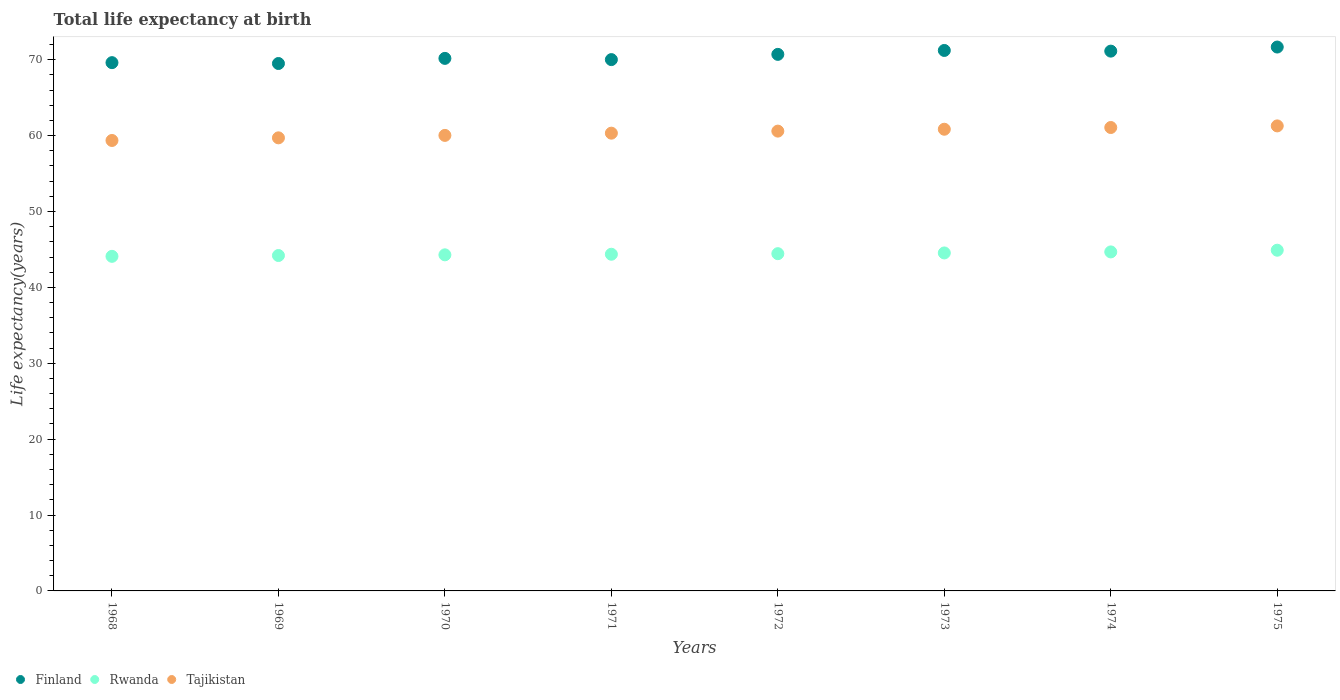How many different coloured dotlines are there?
Your answer should be very brief. 3. What is the life expectancy at birth in in Rwanda in 1970?
Your response must be concise. 44.29. Across all years, what is the maximum life expectancy at birth in in Rwanda?
Make the answer very short. 44.9. Across all years, what is the minimum life expectancy at birth in in Tajikistan?
Make the answer very short. 59.36. In which year was the life expectancy at birth in in Tajikistan maximum?
Ensure brevity in your answer.  1975. In which year was the life expectancy at birth in in Finland minimum?
Provide a short and direct response. 1969. What is the total life expectancy at birth in in Finland in the graph?
Provide a succinct answer. 564.06. What is the difference between the life expectancy at birth in in Finland in 1969 and that in 1972?
Your answer should be very brief. -1.2. What is the difference between the life expectancy at birth in in Rwanda in 1971 and the life expectancy at birth in in Tajikistan in 1975?
Make the answer very short. -16.91. What is the average life expectancy at birth in in Tajikistan per year?
Offer a terse response. 60.4. In the year 1968, what is the difference between the life expectancy at birth in in Tajikistan and life expectancy at birth in in Finland?
Make the answer very short. -10.26. In how many years, is the life expectancy at birth in in Finland greater than 48 years?
Keep it short and to the point. 8. What is the ratio of the life expectancy at birth in in Tajikistan in 1974 to that in 1975?
Ensure brevity in your answer.  1. What is the difference between the highest and the second highest life expectancy at birth in in Finland?
Give a very brief answer. 0.45. What is the difference between the highest and the lowest life expectancy at birth in in Tajikistan?
Ensure brevity in your answer.  1.92. Is the sum of the life expectancy at birth in in Tajikistan in 1969 and 1971 greater than the maximum life expectancy at birth in in Finland across all years?
Your answer should be very brief. Yes. Is it the case that in every year, the sum of the life expectancy at birth in in Tajikistan and life expectancy at birth in in Rwanda  is greater than the life expectancy at birth in in Finland?
Your answer should be compact. Yes. Is the life expectancy at birth in in Tajikistan strictly greater than the life expectancy at birth in in Rwanda over the years?
Offer a very short reply. Yes. How many years are there in the graph?
Your answer should be compact. 8. Does the graph contain grids?
Offer a terse response. No. How many legend labels are there?
Your answer should be compact. 3. How are the legend labels stacked?
Your answer should be very brief. Horizontal. What is the title of the graph?
Make the answer very short. Total life expectancy at birth. Does "Kuwait" appear as one of the legend labels in the graph?
Make the answer very short. No. What is the label or title of the Y-axis?
Make the answer very short. Life expectancy(years). What is the Life expectancy(years) in Finland in 1968?
Make the answer very short. 69.62. What is the Life expectancy(years) in Rwanda in 1968?
Offer a terse response. 44.09. What is the Life expectancy(years) in Tajikistan in 1968?
Your answer should be very brief. 59.36. What is the Life expectancy(years) in Finland in 1969?
Ensure brevity in your answer.  69.5. What is the Life expectancy(years) of Rwanda in 1969?
Make the answer very short. 44.2. What is the Life expectancy(years) in Tajikistan in 1969?
Ensure brevity in your answer.  59.71. What is the Life expectancy(years) of Finland in 1970?
Your response must be concise. 70.18. What is the Life expectancy(years) of Rwanda in 1970?
Make the answer very short. 44.29. What is the Life expectancy(years) of Tajikistan in 1970?
Offer a very short reply. 60.03. What is the Life expectancy(years) in Finland in 1971?
Your answer should be very brief. 70.02. What is the Life expectancy(years) in Rwanda in 1971?
Provide a succinct answer. 44.37. What is the Life expectancy(years) of Tajikistan in 1971?
Make the answer very short. 60.32. What is the Life expectancy(years) of Finland in 1972?
Make the answer very short. 70.71. What is the Life expectancy(years) of Rwanda in 1972?
Ensure brevity in your answer.  44.44. What is the Life expectancy(years) of Tajikistan in 1972?
Make the answer very short. 60.59. What is the Life expectancy(years) of Finland in 1973?
Offer a very short reply. 71.22. What is the Life expectancy(years) in Rwanda in 1973?
Provide a short and direct response. 44.54. What is the Life expectancy(years) of Tajikistan in 1973?
Offer a very short reply. 60.84. What is the Life expectancy(years) in Finland in 1974?
Provide a succinct answer. 71.13. What is the Life expectancy(years) in Rwanda in 1974?
Your response must be concise. 44.67. What is the Life expectancy(years) of Tajikistan in 1974?
Ensure brevity in your answer.  61.07. What is the Life expectancy(years) in Finland in 1975?
Your answer should be compact. 71.67. What is the Life expectancy(years) in Rwanda in 1975?
Provide a succinct answer. 44.9. What is the Life expectancy(years) in Tajikistan in 1975?
Your answer should be compact. 61.28. Across all years, what is the maximum Life expectancy(years) in Finland?
Offer a very short reply. 71.67. Across all years, what is the maximum Life expectancy(years) of Rwanda?
Your answer should be compact. 44.9. Across all years, what is the maximum Life expectancy(years) of Tajikistan?
Ensure brevity in your answer.  61.28. Across all years, what is the minimum Life expectancy(years) of Finland?
Make the answer very short. 69.5. Across all years, what is the minimum Life expectancy(years) in Rwanda?
Your answer should be compact. 44.09. Across all years, what is the minimum Life expectancy(years) of Tajikistan?
Provide a short and direct response. 59.36. What is the total Life expectancy(years) of Finland in the graph?
Ensure brevity in your answer.  564.06. What is the total Life expectancy(years) in Rwanda in the graph?
Keep it short and to the point. 355.51. What is the total Life expectancy(years) in Tajikistan in the graph?
Provide a short and direct response. 483.21. What is the difference between the Life expectancy(years) in Finland in 1968 and that in 1969?
Offer a terse response. 0.11. What is the difference between the Life expectancy(years) in Rwanda in 1968 and that in 1969?
Your answer should be very brief. -0.11. What is the difference between the Life expectancy(years) in Tajikistan in 1968 and that in 1969?
Keep it short and to the point. -0.35. What is the difference between the Life expectancy(years) in Finland in 1968 and that in 1970?
Keep it short and to the point. -0.56. What is the difference between the Life expectancy(years) of Rwanda in 1968 and that in 1970?
Offer a terse response. -0.2. What is the difference between the Life expectancy(years) in Tajikistan in 1968 and that in 1970?
Give a very brief answer. -0.67. What is the difference between the Life expectancy(years) of Finland in 1968 and that in 1971?
Your response must be concise. -0.4. What is the difference between the Life expectancy(years) in Rwanda in 1968 and that in 1971?
Make the answer very short. -0.28. What is the difference between the Life expectancy(years) of Tajikistan in 1968 and that in 1971?
Provide a short and direct response. -0.96. What is the difference between the Life expectancy(years) in Finland in 1968 and that in 1972?
Keep it short and to the point. -1.09. What is the difference between the Life expectancy(years) in Rwanda in 1968 and that in 1972?
Make the answer very short. -0.35. What is the difference between the Life expectancy(years) of Tajikistan in 1968 and that in 1972?
Your answer should be very brief. -1.23. What is the difference between the Life expectancy(years) of Finland in 1968 and that in 1973?
Offer a very short reply. -1.61. What is the difference between the Life expectancy(years) in Rwanda in 1968 and that in 1973?
Provide a short and direct response. -0.45. What is the difference between the Life expectancy(years) in Tajikistan in 1968 and that in 1973?
Your answer should be compact. -1.48. What is the difference between the Life expectancy(years) in Finland in 1968 and that in 1974?
Provide a short and direct response. -1.52. What is the difference between the Life expectancy(years) of Rwanda in 1968 and that in 1974?
Give a very brief answer. -0.58. What is the difference between the Life expectancy(years) in Tajikistan in 1968 and that in 1974?
Ensure brevity in your answer.  -1.71. What is the difference between the Life expectancy(years) in Finland in 1968 and that in 1975?
Ensure brevity in your answer.  -2.06. What is the difference between the Life expectancy(years) of Rwanda in 1968 and that in 1975?
Offer a terse response. -0.81. What is the difference between the Life expectancy(years) in Tajikistan in 1968 and that in 1975?
Make the answer very short. -1.92. What is the difference between the Life expectancy(years) of Finland in 1969 and that in 1970?
Provide a short and direct response. -0.68. What is the difference between the Life expectancy(years) in Rwanda in 1969 and that in 1970?
Offer a terse response. -0.09. What is the difference between the Life expectancy(years) in Tajikistan in 1969 and that in 1970?
Make the answer very short. -0.32. What is the difference between the Life expectancy(years) in Finland in 1969 and that in 1971?
Offer a very short reply. -0.51. What is the difference between the Life expectancy(years) in Rwanda in 1969 and that in 1971?
Your response must be concise. -0.17. What is the difference between the Life expectancy(years) in Tajikistan in 1969 and that in 1971?
Provide a short and direct response. -0.62. What is the difference between the Life expectancy(years) of Finland in 1969 and that in 1972?
Offer a very short reply. -1.2. What is the difference between the Life expectancy(years) in Rwanda in 1969 and that in 1972?
Provide a succinct answer. -0.24. What is the difference between the Life expectancy(years) in Tajikistan in 1969 and that in 1972?
Offer a terse response. -0.89. What is the difference between the Life expectancy(years) in Finland in 1969 and that in 1973?
Your answer should be compact. -1.72. What is the difference between the Life expectancy(years) in Rwanda in 1969 and that in 1973?
Provide a short and direct response. -0.34. What is the difference between the Life expectancy(years) in Tajikistan in 1969 and that in 1973?
Offer a very short reply. -1.13. What is the difference between the Life expectancy(years) in Finland in 1969 and that in 1974?
Keep it short and to the point. -1.63. What is the difference between the Life expectancy(years) in Rwanda in 1969 and that in 1974?
Offer a terse response. -0.48. What is the difference between the Life expectancy(years) of Tajikistan in 1969 and that in 1974?
Give a very brief answer. -1.36. What is the difference between the Life expectancy(years) of Finland in 1969 and that in 1975?
Offer a terse response. -2.17. What is the difference between the Life expectancy(years) in Rwanda in 1969 and that in 1975?
Offer a terse response. -0.7. What is the difference between the Life expectancy(years) of Tajikistan in 1969 and that in 1975?
Make the answer very short. -1.57. What is the difference between the Life expectancy(years) of Finland in 1970 and that in 1971?
Provide a short and direct response. 0.16. What is the difference between the Life expectancy(years) in Rwanda in 1970 and that in 1971?
Your answer should be compact. -0.08. What is the difference between the Life expectancy(years) in Tajikistan in 1970 and that in 1971?
Your answer should be compact. -0.29. What is the difference between the Life expectancy(years) in Finland in 1970 and that in 1972?
Offer a terse response. -0.53. What is the difference between the Life expectancy(years) in Rwanda in 1970 and that in 1972?
Offer a terse response. -0.15. What is the difference between the Life expectancy(years) in Tajikistan in 1970 and that in 1972?
Provide a succinct answer. -0.56. What is the difference between the Life expectancy(years) of Finland in 1970 and that in 1973?
Offer a very short reply. -1.04. What is the difference between the Life expectancy(years) in Rwanda in 1970 and that in 1973?
Provide a short and direct response. -0.25. What is the difference between the Life expectancy(years) of Tajikistan in 1970 and that in 1973?
Give a very brief answer. -0.81. What is the difference between the Life expectancy(years) of Finland in 1970 and that in 1974?
Your answer should be very brief. -0.96. What is the difference between the Life expectancy(years) in Rwanda in 1970 and that in 1974?
Your answer should be very brief. -0.38. What is the difference between the Life expectancy(years) of Tajikistan in 1970 and that in 1974?
Provide a short and direct response. -1.04. What is the difference between the Life expectancy(years) in Finland in 1970 and that in 1975?
Offer a very short reply. -1.49. What is the difference between the Life expectancy(years) in Rwanda in 1970 and that in 1975?
Your answer should be compact. -0.61. What is the difference between the Life expectancy(years) in Tajikistan in 1970 and that in 1975?
Make the answer very short. -1.25. What is the difference between the Life expectancy(years) of Finland in 1971 and that in 1972?
Make the answer very short. -0.69. What is the difference between the Life expectancy(years) in Rwanda in 1971 and that in 1972?
Your response must be concise. -0.08. What is the difference between the Life expectancy(years) in Tajikistan in 1971 and that in 1972?
Ensure brevity in your answer.  -0.27. What is the difference between the Life expectancy(years) in Finland in 1971 and that in 1973?
Keep it short and to the point. -1.21. What is the difference between the Life expectancy(years) of Rwanda in 1971 and that in 1973?
Offer a very short reply. -0.17. What is the difference between the Life expectancy(years) in Tajikistan in 1971 and that in 1973?
Your response must be concise. -0.52. What is the difference between the Life expectancy(years) of Finland in 1971 and that in 1974?
Your answer should be very brief. -1.12. What is the difference between the Life expectancy(years) of Rwanda in 1971 and that in 1974?
Offer a very short reply. -0.31. What is the difference between the Life expectancy(years) in Tajikistan in 1971 and that in 1974?
Keep it short and to the point. -0.75. What is the difference between the Life expectancy(years) of Finland in 1971 and that in 1975?
Your response must be concise. -1.66. What is the difference between the Life expectancy(years) in Rwanda in 1971 and that in 1975?
Your answer should be very brief. -0.53. What is the difference between the Life expectancy(years) in Tajikistan in 1971 and that in 1975?
Offer a very short reply. -0.96. What is the difference between the Life expectancy(years) in Finland in 1972 and that in 1973?
Make the answer very short. -0.52. What is the difference between the Life expectancy(years) of Rwanda in 1972 and that in 1973?
Keep it short and to the point. -0.1. What is the difference between the Life expectancy(years) in Tajikistan in 1972 and that in 1973?
Make the answer very short. -0.25. What is the difference between the Life expectancy(years) of Finland in 1972 and that in 1974?
Your answer should be very brief. -0.43. What is the difference between the Life expectancy(years) in Rwanda in 1972 and that in 1974?
Your answer should be compact. -0.23. What is the difference between the Life expectancy(years) in Tajikistan in 1972 and that in 1974?
Give a very brief answer. -0.47. What is the difference between the Life expectancy(years) of Finland in 1972 and that in 1975?
Make the answer very short. -0.97. What is the difference between the Life expectancy(years) in Rwanda in 1972 and that in 1975?
Your answer should be very brief. -0.46. What is the difference between the Life expectancy(years) of Tajikistan in 1972 and that in 1975?
Your response must be concise. -0.69. What is the difference between the Life expectancy(years) of Finland in 1973 and that in 1974?
Offer a terse response. 0.09. What is the difference between the Life expectancy(years) of Rwanda in 1973 and that in 1974?
Offer a very short reply. -0.14. What is the difference between the Life expectancy(years) of Tajikistan in 1973 and that in 1974?
Offer a terse response. -0.23. What is the difference between the Life expectancy(years) in Finland in 1973 and that in 1975?
Provide a succinct answer. -0.45. What is the difference between the Life expectancy(years) in Rwanda in 1973 and that in 1975?
Offer a very short reply. -0.36. What is the difference between the Life expectancy(years) in Tajikistan in 1973 and that in 1975?
Give a very brief answer. -0.44. What is the difference between the Life expectancy(years) of Finland in 1974 and that in 1975?
Keep it short and to the point. -0.54. What is the difference between the Life expectancy(years) in Rwanda in 1974 and that in 1975?
Your response must be concise. -0.22. What is the difference between the Life expectancy(years) of Tajikistan in 1974 and that in 1975?
Your response must be concise. -0.21. What is the difference between the Life expectancy(years) of Finland in 1968 and the Life expectancy(years) of Rwanda in 1969?
Provide a short and direct response. 25.42. What is the difference between the Life expectancy(years) in Finland in 1968 and the Life expectancy(years) in Tajikistan in 1969?
Provide a short and direct response. 9.91. What is the difference between the Life expectancy(years) in Rwanda in 1968 and the Life expectancy(years) in Tajikistan in 1969?
Ensure brevity in your answer.  -15.62. What is the difference between the Life expectancy(years) of Finland in 1968 and the Life expectancy(years) of Rwanda in 1970?
Provide a succinct answer. 25.33. What is the difference between the Life expectancy(years) in Finland in 1968 and the Life expectancy(years) in Tajikistan in 1970?
Make the answer very short. 9.59. What is the difference between the Life expectancy(years) in Rwanda in 1968 and the Life expectancy(years) in Tajikistan in 1970?
Offer a terse response. -15.94. What is the difference between the Life expectancy(years) of Finland in 1968 and the Life expectancy(years) of Rwanda in 1971?
Keep it short and to the point. 25.25. What is the difference between the Life expectancy(years) of Finland in 1968 and the Life expectancy(years) of Tajikistan in 1971?
Your answer should be compact. 9.29. What is the difference between the Life expectancy(years) of Rwanda in 1968 and the Life expectancy(years) of Tajikistan in 1971?
Your response must be concise. -16.23. What is the difference between the Life expectancy(years) of Finland in 1968 and the Life expectancy(years) of Rwanda in 1972?
Ensure brevity in your answer.  25.17. What is the difference between the Life expectancy(years) of Finland in 1968 and the Life expectancy(years) of Tajikistan in 1972?
Your response must be concise. 9.02. What is the difference between the Life expectancy(years) of Rwanda in 1968 and the Life expectancy(years) of Tajikistan in 1972?
Keep it short and to the point. -16.5. What is the difference between the Life expectancy(years) of Finland in 1968 and the Life expectancy(years) of Rwanda in 1973?
Your response must be concise. 25.08. What is the difference between the Life expectancy(years) of Finland in 1968 and the Life expectancy(years) of Tajikistan in 1973?
Ensure brevity in your answer.  8.77. What is the difference between the Life expectancy(years) of Rwanda in 1968 and the Life expectancy(years) of Tajikistan in 1973?
Ensure brevity in your answer.  -16.75. What is the difference between the Life expectancy(years) in Finland in 1968 and the Life expectancy(years) in Rwanda in 1974?
Ensure brevity in your answer.  24.94. What is the difference between the Life expectancy(years) in Finland in 1968 and the Life expectancy(years) in Tajikistan in 1974?
Your answer should be very brief. 8.55. What is the difference between the Life expectancy(years) of Rwanda in 1968 and the Life expectancy(years) of Tajikistan in 1974?
Make the answer very short. -16.98. What is the difference between the Life expectancy(years) of Finland in 1968 and the Life expectancy(years) of Rwanda in 1975?
Give a very brief answer. 24.72. What is the difference between the Life expectancy(years) of Finland in 1968 and the Life expectancy(years) of Tajikistan in 1975?
Your answer should be very brief. 8.34. What is the difference between the Life expectancy(years) in Rwanda in 1968 and the Life expectancy(years) in Tajikistan in 1975?
Give a very brief answer. -17.19. What is the difference between the Life expectancy(years) in Finland in 1969 and the Life expectancy(years) in Rwanda in 1970?
Provide a succinct answer. 25.21. What is the difference between the Life expectancy(years) in Finland in 1969 and the Life expectancy(years) in Tajikistan in 1970?
Make the answer very short. 9.47. What is the difference between the Life expectancy(years) in Rwanda in 1969 and the Life expectancy(years) in Tajikistan in 1970?
Give a very brief answer. -15.83. What is the difference between the Life expectancy(years) of Finland in 1969 and the Life expectancy(years) of Rwanda in 1971?
Keep it short and to the point. 25.14. What is the difference between the Life expectancy(years) in Finland in 1969 and the Life expectancy(years) in Tajikistan in 1971?
Your answer should be compact. 9.18. What is the difference between the Life expectancy(years) in Rwanda in 1969 and the Life expectancy(years) in Tajikistan in 1971?
Provide a succinct answer. -16.12. What is the difference between the Life expectancy(years) of Finland in 1969 and the Life expectancy(years) of Rwanda in 1972?
Your answer should be very brief. 25.06. What is the difference between the Life expectancy(years) of Finland in 1969 and the Life expectancy(years) of Tajikistan in 1972?
Keep it short and to the point. 8.91. What is the difference between the Life expectancy(years) in Rwanda in 1969 and the Life expectancy(years) in Tajikistan in 1972?
Provide a short and direct response. -16.39. What is the difference between the Life expectancy(years) in Finland in 1969 and the Life expectancy(years) in Rwanda in 1973?
Your response must be concise. 24.96. What is the difference between the Life expectancy(years) of Finland in 1969 and the Life expectancy(years) of Tajikistan in 1973?
Make the answer very short. 8.66. What is the difference between the Life expectancy(years) in Rwanda in 1969 and the Life expectancy(years) in Tajikistan in 1973?
Make the answer very short. -16.64. What is the difference between the Life expectancy(years) of Finland in 1969 and the Life expectancy(years) of Rwanda in 1974?
Your answer should be very brief. 24.83. What is the difference between the Life expectancy(years) in Finland in 1969 and the Life expectancy(years) in Tajikistan in 1974?
Ensure brevity in your answer.  8.43. What is the difference between the Life expectancy(years) of Rwanda in 1969 and the Life expectancy(years) of Tajikistan in 1974?
Provide a short and direct response. -16.87. What is the difference between the Life expectancy(years) of Finland in 1969 and the Life expectancy(years) of Rwanda in 1975?
Ensure brevity in your answer.  24.6. What is the difference between the Life expectancy(years) in Finland in 1969 and the Life expectancy(years) in Tajikistan in 1975?
Keep it short and to the point. 8.22. What is the difference between the Life expectancy(years) of Rwanda in 1969 and the Life expectancy(years) of Tajikistan in 1975?
Give a very brief answer. -17.08. What is the difference between the Life expectancy(years) in Finland in 1970 and the Life expectancy(years) in Rwanda in 1971?
Provide a short and direct response. 25.81. What is the difference between the Life expectancy(years) of Finland in 1970 and the Life expectancy(years) of Tajikistan in 1971?
Keep it short and to the point. 9.86. What is the difference between the Life expectancy(years) of Rwanda in 1970 and the Life expectancy(years) of Tajikistan in 1971?
Ensure brevity in your answer.  -16.03. What is the difference between the Life expectancy(years) of Finland in 1970 and the Life expectancy(years) of Rwanda in 1972?
Give a very brief answer. 25.74. What is the difference between the Life expectancy(years) of Finland in 1970 and the Life expectancy(years) of Tajikistan in 1972?
Your answer should be compact. 9.59. What is the difference between the Life expectancy(years) in Rwanda in 1970 and the Life expectancy(years) in Tajikistan in 1972?
Give a very brief answer. -16.3. What is the difference between the Life expectancy(years) in Finland in 1970 and the Life expectancy(years) in Rwanda in 1973?
Provide a succinct answer. 25.64. What is the difference between the Life expectancy(years) in Finland in 1970 and the Life expectancy(years) in Tajikistan in 1973?
Offer a terse response. 9.34. What is the difference between the Life expectancy(years) in Rwanda in 1970 and the Life expectancy(years) in Tajikistan in 1973?
Give a very brief answer. -16.55. What is the difference between the Life expectancy(years) in Finland in 1970 and the Life expectancy(years) in Rwanda in 1974?
Provide a short and direct response. 25.5. What is the difference between the Life expectancy(years) in Finland in 1970 and the Life expectancy(years) in Tajikistan in 1974?
Ensure brevity in your answer.  9.11. What is the difference between the Life expectancy(years) of Rwanda in 1970 and the Life expectancy(years) of Tajikistan in 1974?
Ensure brevity in your answer.  -16.78. What is the difference between the Life expectancy(years) of Finland in 1970 and the Life expectancy(years) of Rwanda in 1975?
Provide a short and direct response. 25.28. What is the difference between the Life expectancy(years) in Finland in 1970 and the Life expectancy(years) in Tajikistan in 1975?
Your response must be concise. 8.9. What is the difference between the Life expectancy(years) in Rwanda in 1970 and the Life expectancy(years) in Tajikistan in 1975?
Provide a short and direct response. -16.99. What is the difference between the Life expectancy(years) of Finland in 1971 and the Life expectancy(years) of Rwanda in 1972?
Provide a succinct answer. 25.57. What is the difference between the Life expectancy(years) in Finland in 1971 and the Life expectancy(years) in Tajikistan in 1972?
Provide a short and direct response. 9.42. What is the difference between the Life expectancy(years) in Rwanda in 1971 and the Life expectancy(years) in Tajikistan in 1972?
Your answer should be very brief. -16.23. What is the difference between the Life expectancy(years) in Finland in 1971 and the Life expectancy(years) in Rwanda in 1973?
Provide a short and direct response. 25.48. What is the difference between the Life expectancy(years) of Finland in 1971 and the Life expectancy(years) of Tajikistan in 1973?
Provide a succinct answer. 9.18. What is the difference between the Life expectancy(years) of Rwanda in 1971 and the Life expectancy(years) of Tajikistan in 1973?
Your answer should be compact. -16.47. What is the difference between the Life expectancy(years) in Finland in 1971 and the Life expectancy(years) in Rwanda in 1974?
Your answer should be very brief. 25.34. What is the difference between the Life expectancy(years) in Finland in 1971 and the Life expectancy(years) in Tajikistan in 1974?
Ensure brevity in your answer.  8.95. What is the difference between the Life expectancy(years) in Rwanda in 1971 and the Life expectancy(years) in Tajikistan in 1974?
Provide a succinct answer. -16.7. What is the difference between the Life expectancy(years) of Finland in 1971 and the Life expectancy(years) of Rwanda in 1975?
Offer a terse response. 25.12. What is the difference between the Life expectancy(years) of Finland in 1971 and the Life expectancy(years) of Tajikistan in 1975?
Keep it short and to the point. 8.74. What is the difference between the Life expectancy(years) in Rwanda in 1971 and the Life expectancy(years) in Tajikistan in 1975?
Offer a very short reply. -16.91. What is the difference between the Life expectancy(years) in Finland in 1972 and the Life expectancy(years) in Rwanda in 1973?
Your answer should be very brief. 26.17. What is the difference between the Life expectancy(years) of Finland in 1972 and the Life expectancy(years) of Tajikistan in 1973?
Offer a terse response. 9.87. What is the difference between the Life expectancy(years) of Rwanda in 1972 and the Life expectancy(years) of Tajikistan in 1973?
Make the answer very short. -16.4. What is the difference between the Life expectancy(years) in Finland in 1972 and the Life expectancy(years) in Rwanda in 1974?
Ensure brevity in your answer.  26.03. What is the difference between the Life expectancy(years) of Finland in 1972 and the Life expectancy(years) of Tajikistan in 1974?
Your answer should be very brief. 9.64. What is the difference between the Life expectancy(years) of Rwanda in 1972 and the Life expectancy(years) of Tajikistan in 1974?
Offer a very short reply. -16.63. What is the difference between the Life expectancy(years) in Finland in 1972 and the Life expectancy(years) in Rwanda in 1975?
Give a very brief answer. 25.81. What is the difference between the Life expectancy(years) in Finland in 1972 and the Life expectancy(years) in Tajikistan in 1975?
Provide a succinct answer. 9.43. What is the difference between the Life expectancy(years) of Rwanda in 1972 and the Life expectancy(years) of Tajikistan in 1975?
Your answer should be very brief. -16.84. What is the difference between the Life expectancy(years) of Finland in 1973 and the Life expectancy(years) of Rwanda in 1974?
Make the answer very short. 26.55. What is the difference between the Life expectancy(years) of Finland in 1973 and the Life expectancy(years) of Tajikistan in 1974?
Your answer should be compact. 10.15. What is the difference between the Life expectancy(years) of Rwanda in 1973 and the Life expectancy(years) of Tajikistan in 1974?
Provide a short and direct response. -16.53. What is the difference between the Life expectancy(years) in Finland in 1973 and the Life expectancy(years) in Rwanda in 1975?
Provide a short and direct response. 26.32. What is the difference between the Life expectancy(years) of Finland in 1973 and the Life expectancy(years) of Tajikistan in 1975?
Keep it short and to the point. 9.94. What is the difference between the Life expectancy(years) in Rwanda in 1973 and the Life expectancy(years) in Tajikistan in 1975?
Give a very brief answer. -16.74. What is the difference between the Life expectancy(years) in Finland in 1974 and the Life expectancy(years) in Rwanda in 1975?
Your answer should be very brief. 26.24. What is the difference between the Life expectancy(years) in Finland in 1974 and the Life expectancy(years) in Tajikistan in 1975?
Give a very brief answer. 9.85. What is the difference between the Life expectancy(years) of Rwanda in 1974 and the Life expectancy(years) of Tajikistan in 1975?
Offer a terse response. -16.61. What is the average Life expectancy(years) of Finland per year?
Your answer should be compact. 70.51. What is the average Life expectancy(years) of Rwanda per year?
Your response must be concise. 44.44. What is the average Life expectancy(years) of Tajikistan per year?
Keep it short and to the point. 60.4. In the year 1968, what is the difference between the Life expectancy(years) in Finland and Life expectancy(years) in Rwanda?
Ensure brevity in your answer.  25.52. In the year 1968, what is the difference between the Life expectancy(years) in Finland and Life expectancy(years) in Tajikistan?
Offer a very short reply. 10.26. In the year 1968, what is the difference between the Life expectancy(years) in Rwanda and Life expectancy(years) in Tajikistan?
Make the answer very short. -15.27. In the year 1969, what is the difference between the Life expectancy(years) of Finland and Life expectancy(years) of Rwanda?
Your response must be concise. 25.3. In the year 1969, what is the difference between the Life expectancy(years) of Finland and Life expectancy(years) of Tajikistan?
Offer a terse response. 9.8. In the year 1969, what is the difference between the Life expectancy(years) in Rwanda and Life expectancy(years) in Tajikistan?
Give a very brief answer. -15.51. In the year 1970, what is the difference between the Life expectancy(years) of Finland and Life expectancy(years) of Rwanda?
Make the answer very short. 25.89. In the year 1970, what is the difference between the Life expectancy(years) of Finland and Life expectancy(years) of Tajikistan?
Your response must be concise. 10.15. In the year 1970, what is the difference between the Life expectancy(years) of Rwanda and Life expectancy(years) of Tajikistan?
Your answer should be very brief. -15.74. In the year 1971, what is the difference between the Life expectancy(years) of Finland and Life expectancy(years) of Rwanda?
Offer a very short reply. 25.65. In the year 1971, what is the difference between the Life expectancy(years) in Finland and Life expectancy(years) in Tajikistan?
Your answer should be compact. 9.69. In the year 1971, what is the difference between the Life expectancy(years) in Rwanda and Life expectancy(years) in Tajikistan?
Keep it short and to the point. -15.96. In the year 1972, what is the difference between the Life expectancy(years) in Finland and Life expectancy(years) in Rwanda?
Offer a very short reply. 26.26. In the year 1972, what is the difference between the Life expectancy(years) of Finland and Life expectancy(years) of Tajikistan?
Keep it short and to the point. 10.11. In the year 1972, what is the difference between the Life expectancy(years) of Rwanda and Life expectancy(years) of Tajikistan?
Your response must be concise. -16.15. In the year 1973, what is the difference between the Life expectancy(years) in Finland and Life expectancy(years) in Rwanda?
Offer a terse response. 26.68. In the year 1973, what is the difference between the Life expectancy(years) of Finland and Life expectancy(years) of Tajikistan?
Your response must be concise. 10.38. In the year 1973, what is the difference between the Life expectancy(years) in Rwanda and Life expectancy(years) in Tajikistan?
Give a very brief answer. -16.3. In the year 1974, what is the difference between the Life expectancy(years) in Finland and Life expectancy(years) in Rwanda?
Your response must be concise. 26.46. In the year 1974, what is the difference between the Life expectancy(years) of Finland and Life expectancy(years) of Tajikistan?
Your answer should be compact. 10.07. In the year 1974, what is the difference between the Life expectancy(years) in Rwanda and Life expectancy(years) in Tajikistan?
Give a very brief answer. -16.39. In the year 1975, what is the difference between the Life expectancy(years) in Finland and Life expectancy(years) in Rwanda?
Provide a short and direct response. 26.77. In the year 1975, what is the difference between the Life expectancy(years) of Finland and Life expectancy(years) of Tajikistan?
Ensure brevity in your answer.  10.39. In the year 1975, what is the difference between the Life expectancy(years) in Rwanda and Life expectancy(years) in Tajikistan?
Make the answer very short. -16.38. What is the ratio of the Life expectancy(years) in Finland in 1968 to that in 1970?
Keep it short and to the point. 0.99. What is the ratio of the Life expectancy(years) in Tajikistan in 1968 to that in 1970?
Make the answer very short. 0.99. What is the ratio of the Life expectancy(years) in Finland in 1968 to that in 1971?
Make the answer very short. 0.99. What is the ratio of the Life expectancy(years) in Rwanda in 1968 to that in 1971?
Your answer should be compact. 0.99. What is the ratio of the Life expectancy(years) of Tajikistan in 1968 to that in 1971?
Your answer should be very brief. 0.98. What is the ratio of the Life expectancy(years) of Finland in 1968 to that in 1972?
Offer a very short reply. 0.98. What is the ratio of the Life expectancy(years) in Rwanda in 1968 to that in 1972?
Make the answer very short. 0.99. What is the ratio of the Life expectancy(years) of Tajikistan in 1968 to that in 1972?
Keep it short and to the point. 0.98. What is the ratio of the Life expectancy(years) of Finland in 1968 to that in 1973?
Offer a very short reply. 0.98. What is the ratio of the Life expectancy(years) in Rwanda in 1968 to that in 1973?
Provide a succinct answer. 0.99. What is the ratio of the Life expectancy(years) in Tajikistan in 1968 to that in 1973?
Your answer should be very brief. 0.98. What is the ratio of the Life expectancy(years) of Finland in 1968 to that in 1974?
Make the answer very short. 0.98. What is the ratio of the Life expectancy(years) of Rwanda in 1968 to that in 1974?
Provide a short and direct response. 0.99. What is the ratio of the Life expectancy(years) of Tajikistan in 1968 to that in 1974?
Offer a terse response. 0.97. What is the ratio of the Life expectancy(years) of Finland in 1968 to that in 1975?
Your answer should be very brief. 0.97. What is the ratio of the Life expectancy(years) in Tajikistan in 1968 to that in 1975?
Ensure brevity in your answer.  0.97. What is the ratio of the Life expectancy(years) of Rwanda in 1969 to that in 1970?
Provide a succinct answer. 1. What is the ratio of the Life expectancy(years) of Tajikistan in 1969 to that in 1970?
Your answer should be very brief. 0.99. What is the ratio of the Life expectancy(years) of Finland in 1969 to that in 1971?
Offer a very short reply. 0.99. What is the ratio of the Life expectancy(years) in Tajikistan in 1969 to that in 1971?
Offer a terse response. 0.99. What is the ratio of the Life expectancy(years) of Finland in 1969 to that in 1972?
Keep it short and to the point. 0.98. What is the ratio of the Life expectancy(years) in Rwanda in 1969 to that in 1972?
Your response must be concise. 0.99. What is the ratio of the Life expectancy(years) in Tajikistan in 1969 to that in 1972?
Your answer should be compact. 0.99. What is the ratio of the Life expectancy(years) in Finland in 1969 to that in 1973?
Your answer should be compact. 0.98. What is the ratio of the Life expectancy(years) of Tajikistan in 1969 to that in 1973?
Give a very brief answer. 0.98. What is the ratio of the Life expectancy(years) in Finland in 1969 to that in 1974?
Your response must be concise. 0.98. What is the ratio of the Life expectancy(years) in Tajikistan in 1969 to that in 1974?
Your answer should be compact. 0.98. What is the ratio of the Life expectancy(years) in Finland in 1969 to that in 1975?
Your answer should be compact. 0.97. What is the ratio of the Life expectancy(years) of Rwanda in 1969 to that in 1975?
Your answer should be compact. 0.98. What is the ratio of the Life expectancy(years) of Tajikistan in 1969 to that in 1975?
Keep it short and to the point. 0.97. What is the ratio of the Life expectancy(years) in Rwanda in 1970 to that in 1971?
Your answer should be very brief. 1. What is the ratio of the Life expectancy(years) of Rwanda in 1970 to that in 1972?
Provide a succinct answer. 1. What is the ratio of the Life expectancy(years) in Finland in 1970 to that in 1973?
Your response must be concise. 0.99. What is the ratio of the Life expectancy(years) of Rwanda in 1970 to that in 1973?
Keep it short and to the point. 0.99. What is the ratio of the Life expectancy(years) in Tajikistan in 1970 to that in 1973?
Make the answer very short. 0.99. What is the ratio of the Life expectancy(years) in Finland in 1970 to that in 1974?
Your answer should be compact. 0.99. What is the ratio of the Life expectancy(years) of Rwanda in 1970 to that in 1974?
Your answer should be very brief. 0.99. What is the ratio of the Life expectancy(years) in Finland in 1970 to that in 1975?
Offer a terse response. 0.98. What is the ratio of the Life expectancy(years) in Rwanda in 1970 to that in 1975?
Give a very brief answer. 0.99. What is the ratio of the Life expectancy(years) of Tajikistan in 1970 to that in 1975?
Your answer should be very brief. 0.98. What is the ratio of the Life expectancy(years) of Finland in 1971 to that in 1972?
Your answer should be very brief. 0.99. What is the ratio of the Life expectancy(years) in Finland in 1971 to that in 1973?
Make the answer very short. 0.98. What is the ratio of the Life expectancy(years) in Tajikistan in 1971 to that in 1973?
Make the answer very short. 0.99. What is the ratio of the Life expectancy(years) of Finland in 1971 to that in 1974?
Offer a very short reply. 0.98. What is the ratio of the Life expectancy(years) of Rwanda in 1971 to that in 1974?
Make the answer very short. 0.99. What is the ratio of the Life expectancy(years) of Finland in 1971 to that in 1975?
Give a very brief answer. 0.98. What is the ratio of the Life expectancy(years) in Tajikistan in 1971 to that in 1975?
Keep it short and to the point. 0.98. What is the ratio of the Life expectancy(years) of Finland in 1972 to that in 1973?
Your response must be concise. 0.99. What is the ratio of the Life expectancy(years) in Rwanda in 1972 to that in 1973?
Keep it short and to the point. 1. What is the ratio of the Life expectancy(years) in Finland in 1972 to that in 1974?
Provide a short and direct response. 0.99. What is the ratio of the Life expectancy(years) of Tajikistan in 1972 to that in 1974?
Make the answer very short. 0.99. What is the ratio of the Life expectancy(years) of Finland in 1972 to that in 1975?
Offer a very short reply. 0.99. What is the ratio of the Life expectancy(years) in Rwanda in 1972 to that in 1975?
Your answer should be compact. 0.99. What is the ratio of the Life expectancy(years) in Finland in 1973 to that in 1974?
Your answer should be compact. 1. What is the ratio of the Life expectancy(years) in Tajikistan in 1973 to that in 1974?
Your answer should be very brief. 1. What is the ratio of the Life expectancy(years) in Finland in 1973 to that in 1975?
Provide a succinct answer. 0.99. What is the ratio of the Life expectancy(years) in Rwanda in 1973 to that in 1975?
Your response must be concise. 0.99. What is the ratio of the Life expectancy(years) in Tajikistan in 1973 to that in 1975?
Your answer should be compact. 0.99. What is the ratio of the Life expectancy(years) of Rwanda in 1974 to that in 1975?
Keep it short and to the point. 0.99. What is the ratio of the Life expectancy(years) of Tajikistan in 1974 to that in 1975?
Your answer should be very brief. 1. What is the difference between the highest and the second highest Life expectancy(years) in Finland?
Your answer should be compact. 0.45. What is the difference between the highest and the second highest Life expectancy(years) in Rwanda?
Make the answer very short. 0.22. What is the difference between the highest and the second highest Life expectancy(years) in Tajikistan?
Keep it short and to the point. 0.21. What is the difference between the highest and the lowest Life expectancy(years) of Finland?
Make the answer very short. 2.17. What is the difference between the highest and the lowest Life expectancy(years) in Rwanda?
Keep it short and to the point. 0.81. What is the difference between the highest and the lowest Life expectancy(years) of Tajikistan?
Provide a succinct answer. 1.92. 